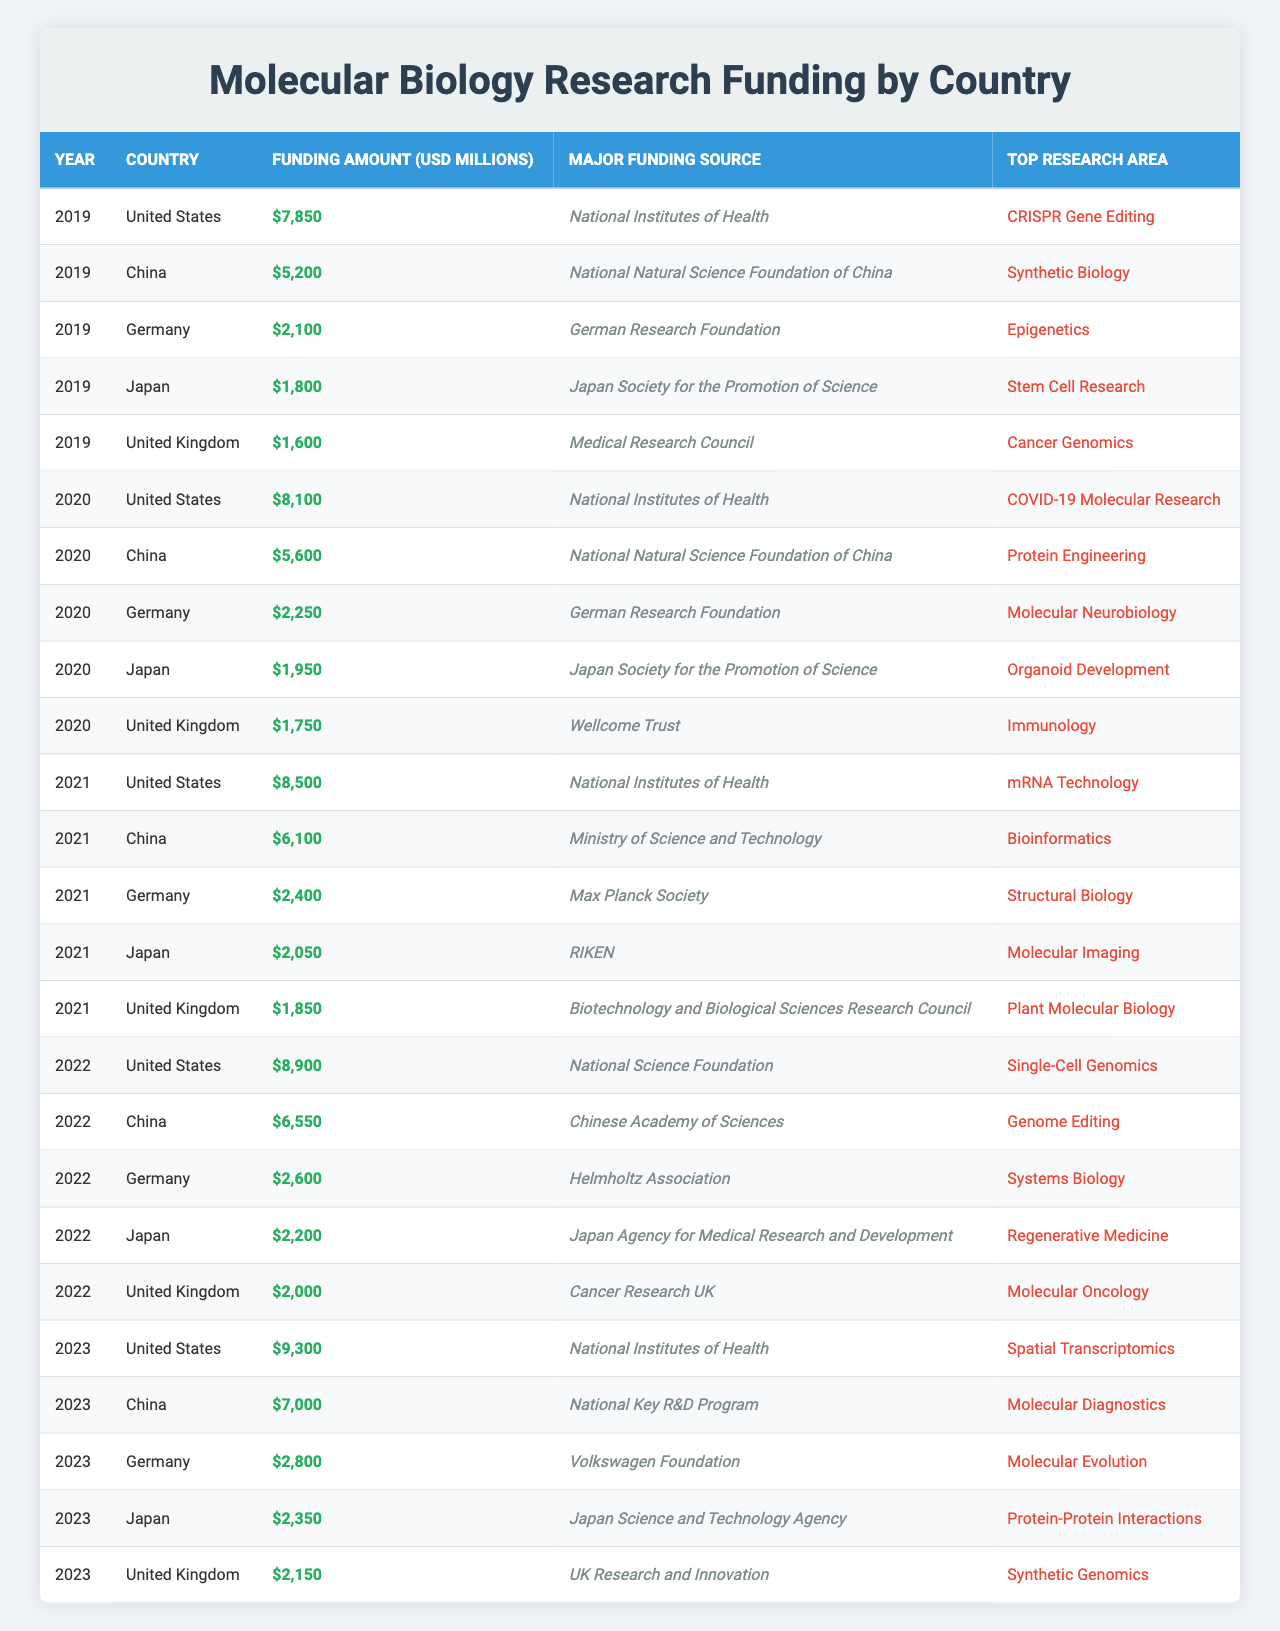What was the highest funding amount for molecular biology research in 2022? The United States received $8,900 million in funding in 2022, which is the highest amount recorded that year.
Answer: 8900 Which country had the lowest funding in 2019? In 2019, Japan received the lowest funding amount of $1,800 million for molecular biology research compared to the other listed countries.
Answer: 1800 How much more funding did the United States receive in 2023 compared to 2020? The United States received $9,300 million in 2023 and $8,100 million in 2020. To find the difference, subtract: 9,300 - 8,100 = $1,200 million.
Answer: 1200 Is it true that Germany's funding increased every year from 2019 to 2023? Reviewing the data, it's clear that Germany's funding rose from $2,100 million in 2019 to $2,800 million in 2023, indicating a consistent increase each year.
Answer: True Which country had the top funding amount in 2021, and what was the main research area funded? The United States had the highest funding amount of $8,500 million in 2021, focusing on mRNA Technology as the main area of research.
Answer: United States, mRNA Technology What is the total funding amount for China over the last five years (2019-2023)? By adding China's funding for each year: 5,200 (2019) + 5,600 (2020) + 6,100 (2021) + 6,550 (2022) + 7,000 (2023) = $30,450 million.
Answer: 30450 Which country consistently received funding from the National Institutes of Health? The United States received funding from the National Institutes of Health every year from 2019 to 2023, indicating a consistent source of funding for its research.
Answer: United States In which year did the United Kingdom receive the most funding? The highest funding for the United Kingdom was recorded in 2023 at $2,150 million, which is more than the amounts received in previous years.
Answer: 2023 What are the major funding sources for molecular biology research in Japan over the years? Japan received funding from various sources: Japan Society for the Promotion of Science (2019, 2020), RIKEN (2021), Japan Agency for Medical Research and Development (2022), and Japan Science and Technology Agency (2023).
Answer: Multiple sources Did the amount funded for Protein Engineering in China rise from 2020 to 2021? Funding for Protein Engineering in China increased from $5,600 million in 2020 to $6,100 million in 2021, indicating a rise.
Answer: Yes What was the difference in funding between the top country and the second top country in 2023? In 2023, the United States received $9,300 million and China received $7,000 million. The difference is $9,300 - $7,000 = $2,300 million.
Answer: 2300 